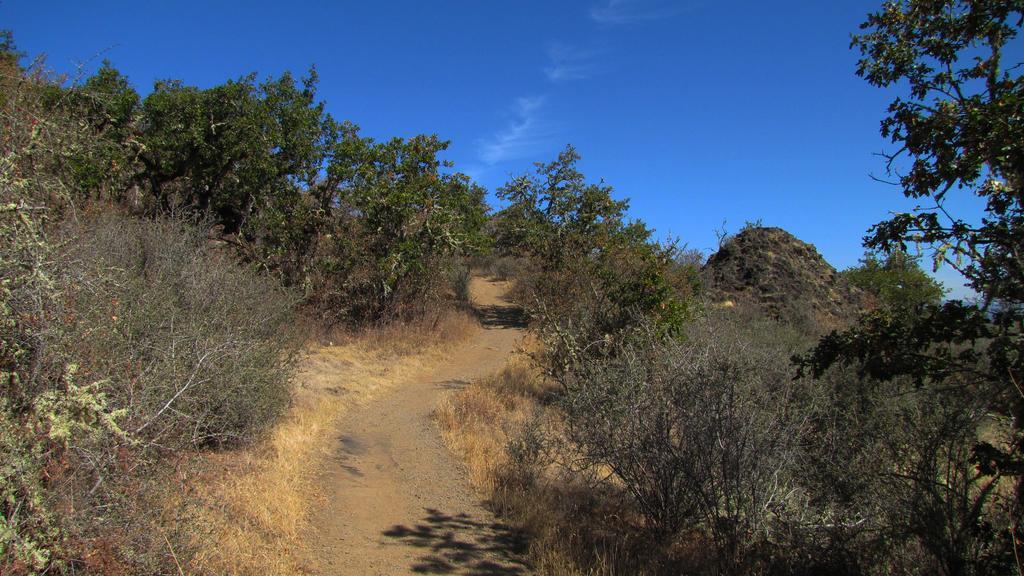In one or two sentences, can you explain what this image depicts? In this picture we can see a few plants and trees on both sides of the image. We can see the sky on top. 